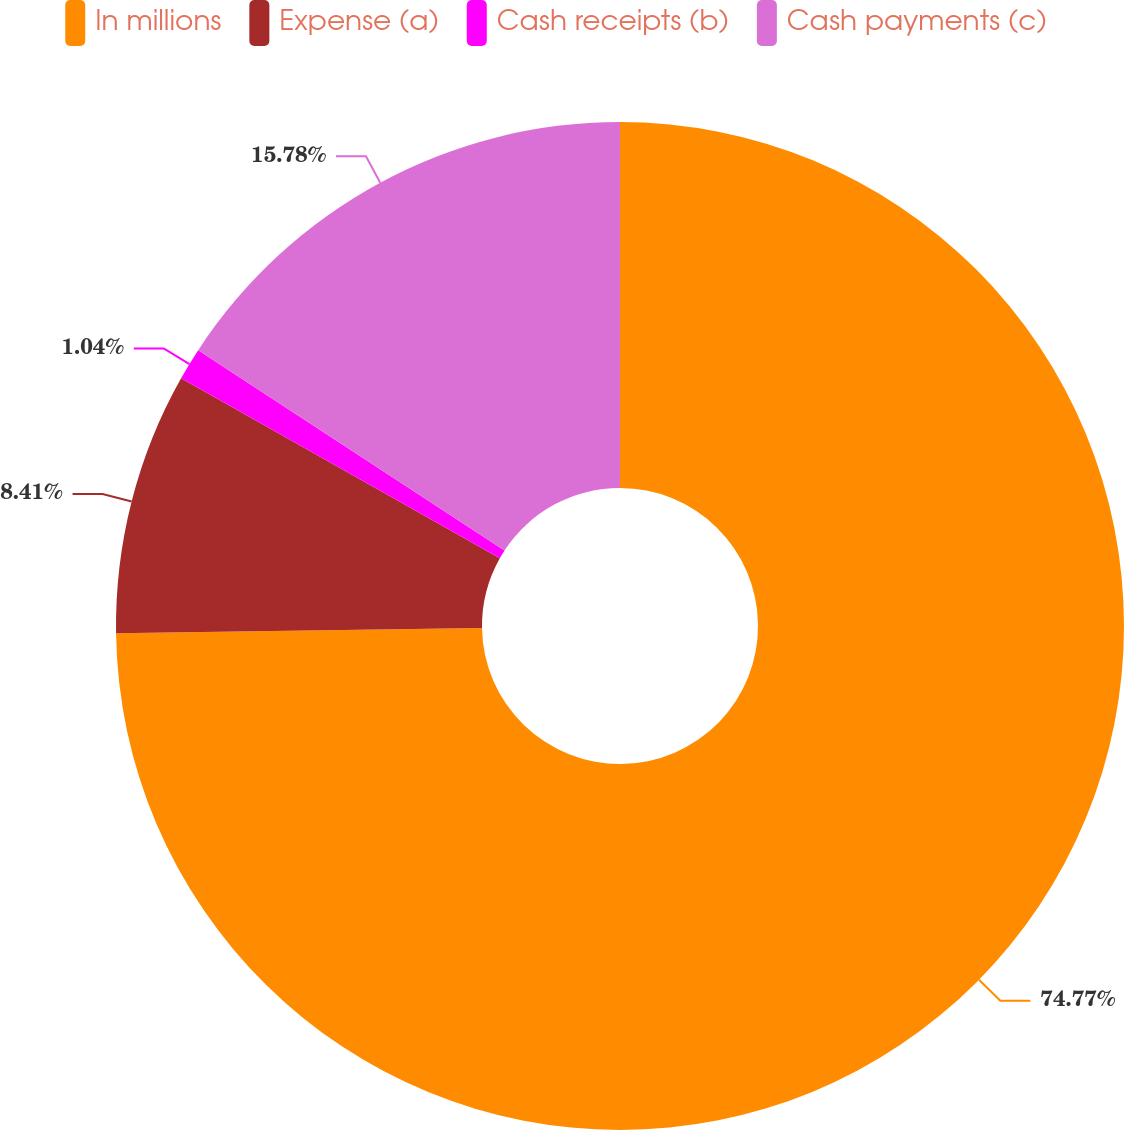Convert chart to OTSL. <chart><loc_0><loc_0><loc_500><loc_500><pie_chart><fcel>In millions<fcel>Expense (a)<fcel>Cash receipts (b)<fcel>Cash payments (c)<nl><fcel>74.76%<fcel>8.41%<fcel>1.04%<fcel>15.78%<nl></chart> 